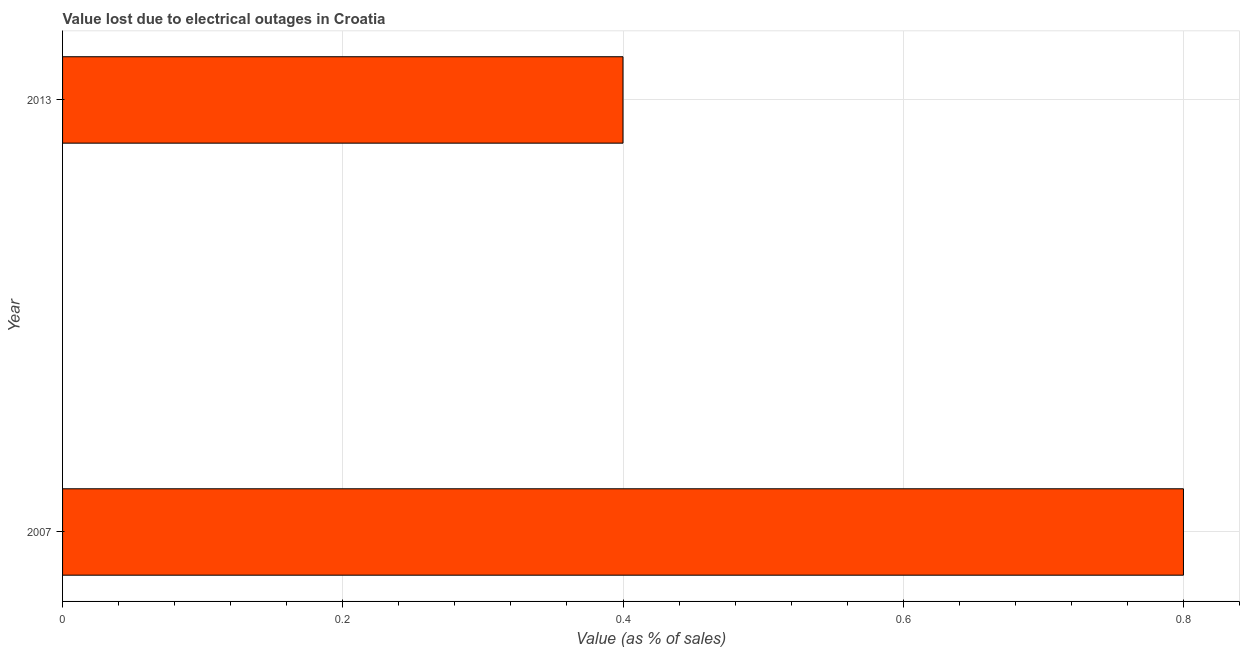Does the graph contain any zero values?
Your answer should be compact. No. Does the graph contain grids?
Provide a succinct answer. Yes. What is the title of the graph?
Your answer should be very brief. Value lost due to electrical outages in Croatia. What is the label or title of the X-axis?
Provide a succinct answer. Value (as % of sales). What is the label or title of the Y-axis?
Provide a succinct answer. Year. Across all years, what is the maximum value lost due to electrical outages?
Offer a very short reply. 0.8. Across all years, what is the minimum value lost due to electrical outages?
Provide a short and direct response. 0.4. In which year was the value lost due to electrical outages minimum?
Ensure brevity in your answer.  2013. What is the sum of the value lost due to electrical outages?
Make the answer very short. 1.2. What is the difference between the value lost due to electrical outages in 2007 and 2013?
Ensure brevity in your answer.  0.4. What is the median value lost due to electrical outages?
Offer a terse response. 0.6. In how many years, is the value lost due to electrical outages greater than 0.8 %?
Provide a succinct answer. 0. What is the ratio of the value lost due to electrical outages in 2007 to that in 2013?
Ensure brevity in your answer.  2. Is the value lost due to electrical outages in 2007 less than that in 2013?
Ensure brevity in your answer.  No. In how many years, is the value lost due to electrical outages greater than the average value lost due to electrical outages taken over all years?
Ensure brevity in your answer.  1. How many years are there in the graph?
Your answer should be compact. 2. What is the difference between two consecutive major ticks on the X-axis?
Offer a terse response. 0.2. Are the values on the major ticks of X-axis written in scientific E-notation?
Offer a very short reply. No. What is the Value (as % of sales) in 2013?
Provide a short and direct response. 0.4. What is the difference between the Value (as % of sales) in 2007 and 2013?
Give a very brief answer. 0.4. What is the ratio of the Value (as % of sales) in 2007 to that in 2013?
Provide a succinct answer. 2. 